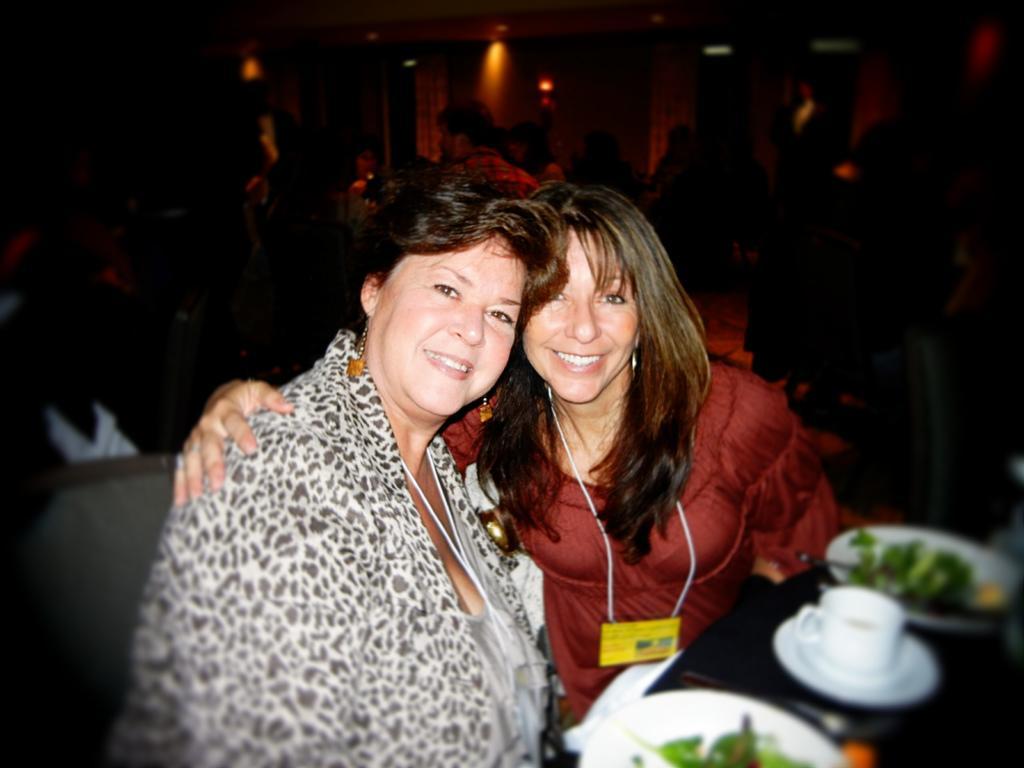Describe this image in one or two sentences. In the image there are two women sitting in front of table with coffee cup,bowl,salad in it, in the back there are few people standing and sitting, this seems to be clicked in a restaurant. 